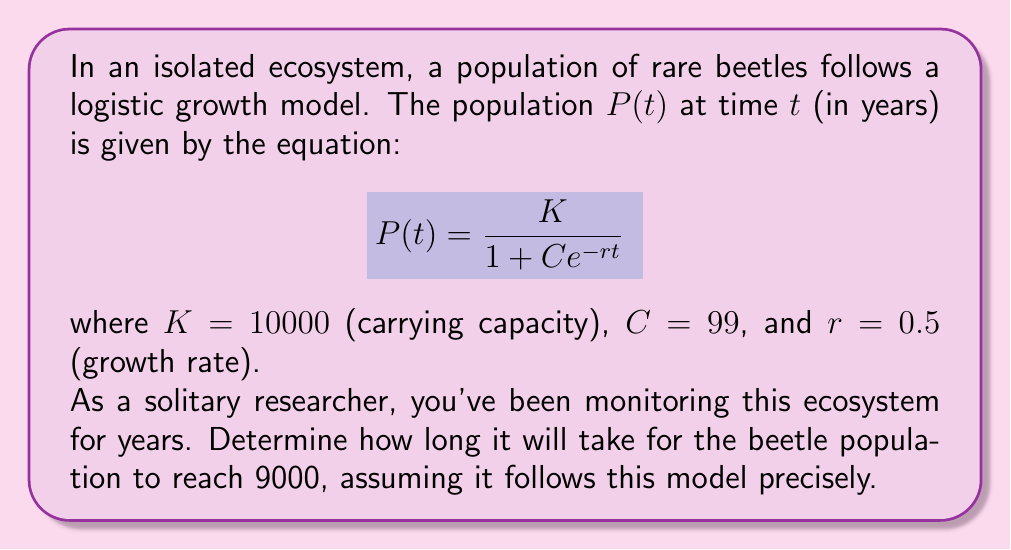Give your solution to this math problem. To solve this problem, we need to use logarithms to isolate $t$. Let's approach this step-by-step:

1) We start with the given equation:
   $$P(t) = \frac{10000}{1 + 99e^{-0.5t}}$$

2) We want to find $t$ when $P(t) = 9000$. So, let's substitute this:
   $$9000 = \frac{10000}{1 + 99e^{-0.5t}}$$

3) Multiply both sides by $(1 + 99e^{-0.5t})$:
   $$9000(1 + 99e^{-0.5t}) = 10000$$

4) Distribute on the left side:
   $$9000 + 891000e^{-0.5t} = 10000$$

5) Subtract 9000 from both sides:
   $$891000e^{-0.5t} = 1000$$

6) Divide both sides by 891000:
   $$e^{-0.5t} = \frac{1}{891}$$

7) Take the natural logarithm of both sides:
   $$\ln(e^{-0.5t}) = \ln(\frac{1}{891})$$

8) Simplify the left side:
   $$-0.5t = \ln(\frac{1}{891})$$

9) Multiply both sides by -2:
   $$t = -2\ln(\frac{1}{891})$$

10) Simplify:
    $$t = 2\ln(891) \approx 13.58$$

Therefore, it will take approximately 13.58 years for the beetle population to reach 9000.
Answer: $t = 2\ln(891) \approx 13.58$ years 